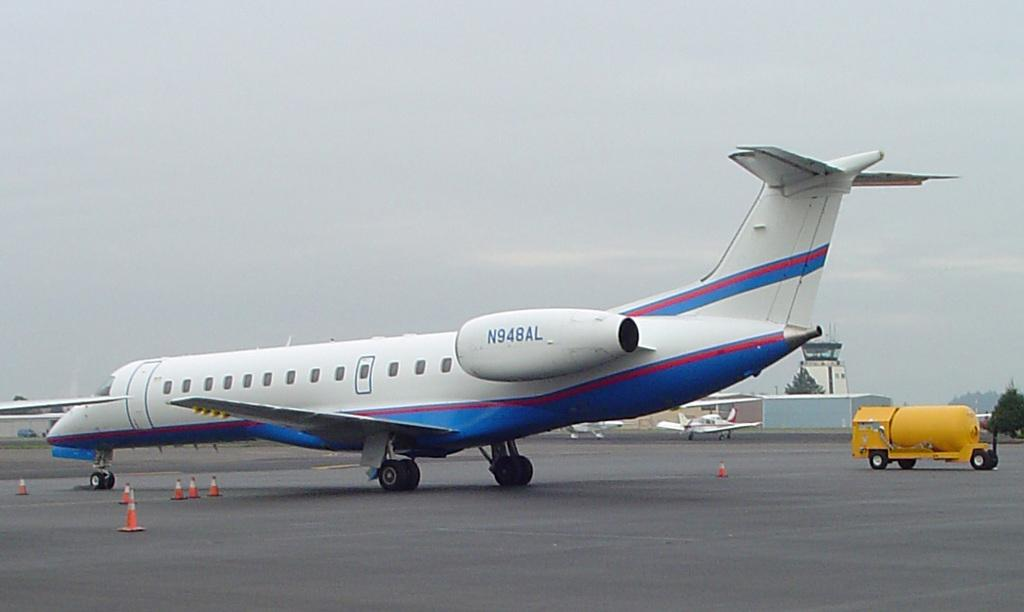<image>
Relay a brief, clear account of the picture shown. An airplane with number N948AL sits on a runway. 